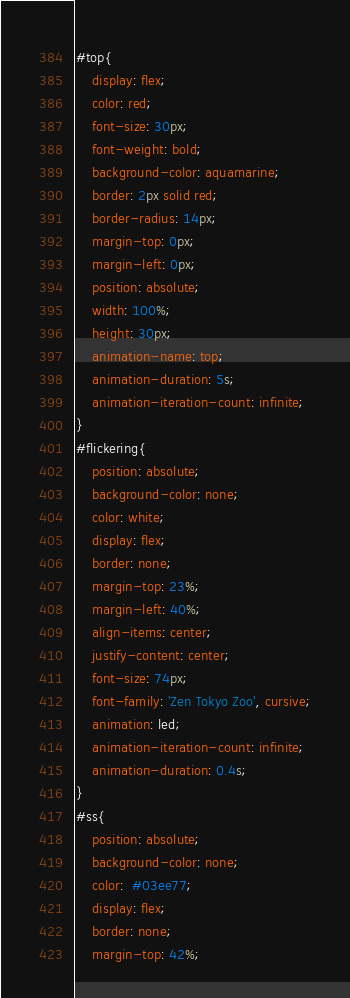<code> <loc_0><loc_0><loc_500><loc_500><_CSS_>#top{
    display: flex;
    color: red;
    font-size: 30px;
    font-weight: bold;
    background-color: aquamarine;
    border: 2px solid red;
    border-radius: 14px;
    margin-top: 0px;
    margin-left: 0px;
    position: absolute;
    width: 100%;
    height: 30px;
    animation-name: top;
    animation-duration: 5s;
    animation-iteration-count: infinite;
}
#flickering{
    position: absolute;
    background-color: none;
    color: white;
    display: flex;
    border: none;
    margin-top: 23%;
    margin-left: 40%;
    align-items: center;
    justify-content: center;
    font-size: 74px;
    font-family: 'Zen Tokyo Zoo', cursive;
    animation: led;
    animation-iteration-count: infinite;
    animation-duration: 0.4s;
}
#ss{
    position: absolute;
    background-color: none;
    color:  #03ee77;
    display: flex;
    border: none;
    margin-top: 42%;</code> 